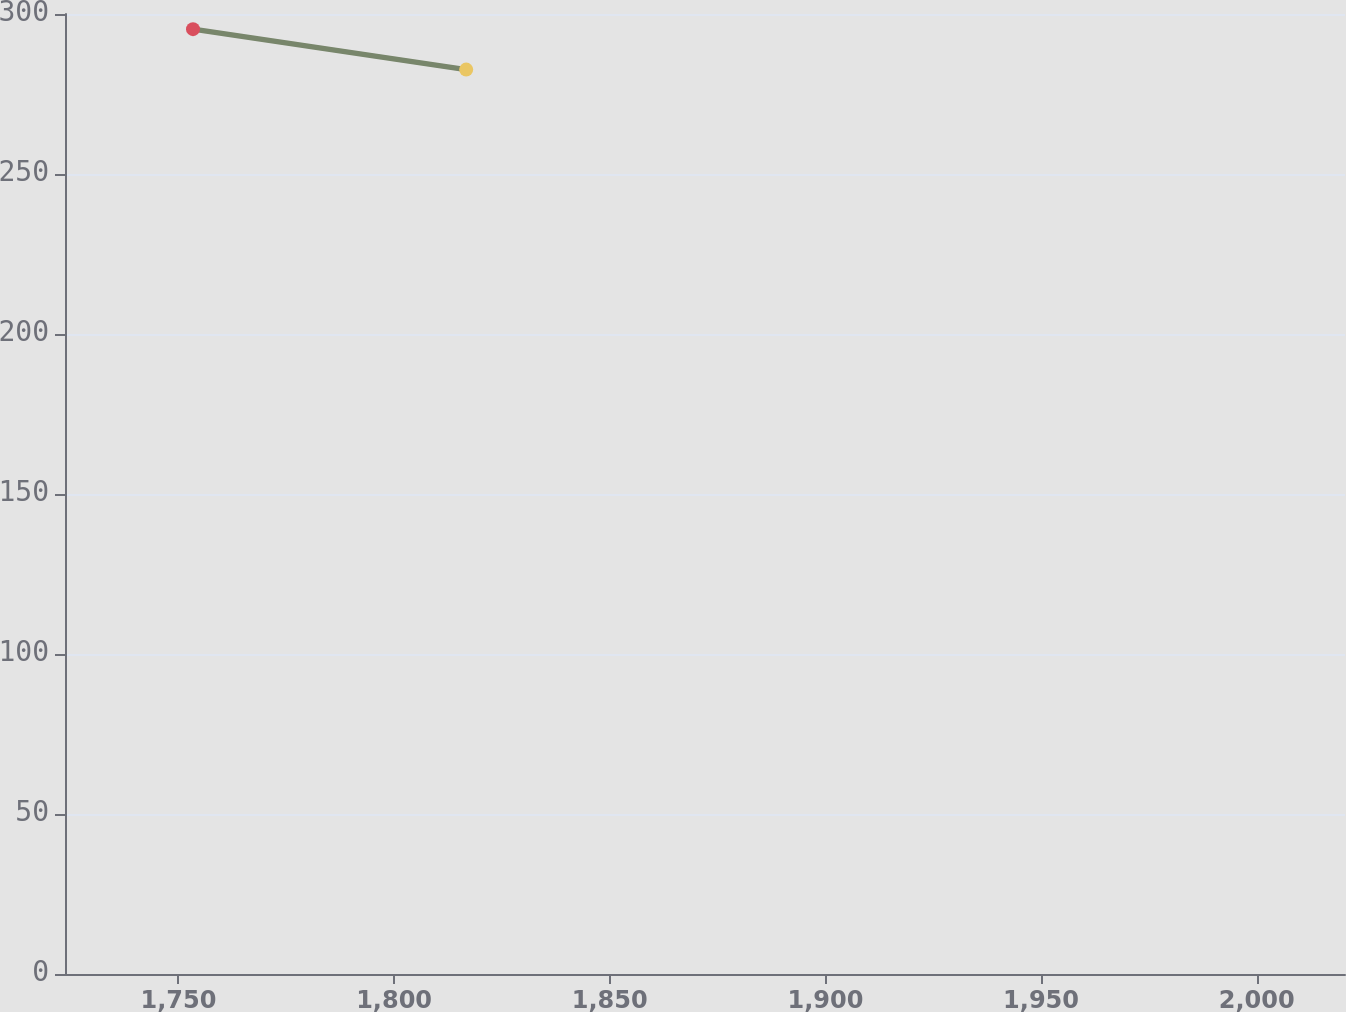Convert chart to OTSL. <chart><loc_0><loc_0><loc_500><loc_500><line_chart><ecel><fcel>346<nl><fcel>1753.37<fcel>295.26<nl><fcel>1816.71<fcel>282.62<nl><fcel>2050.16<fcel>269.69<nl></chart> 